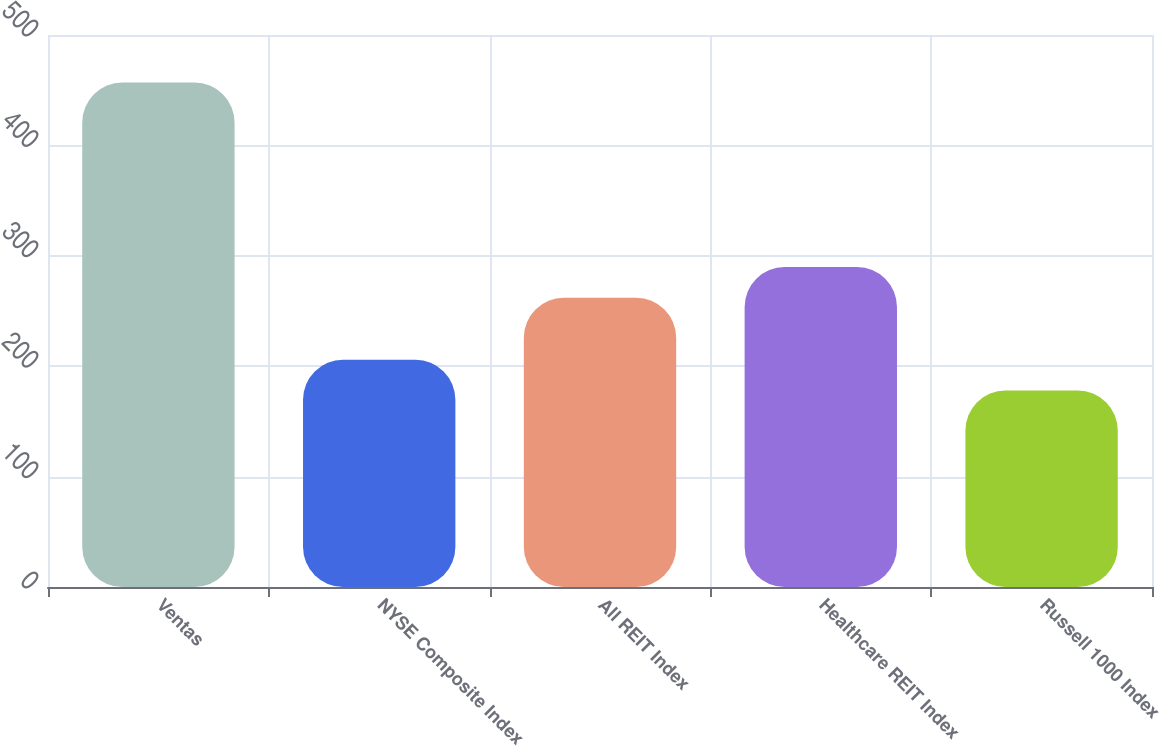Convert chart to OTSL. <chart><loc_0><loc_0><loc_500><loc_500><bar_chart><fcel>Ventas<fcel>NYSE Composite Index<fcel>All REIT Index<fcel>Healthcare REIT Index<fcel>Russell 1000 Index<nl><fcel>457<fcel>205.9<fcel>262<fcel>289.9<fcel>178<nl></chart> 